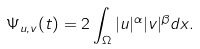<formula> <loc_0><loc_0><loc_500><loc_500>\Psi _ { u , v } ( t ) = 2 \int _ { \Omega } | u | ^ { \alpha } | v | ^ { \beta } d x .</formula> 